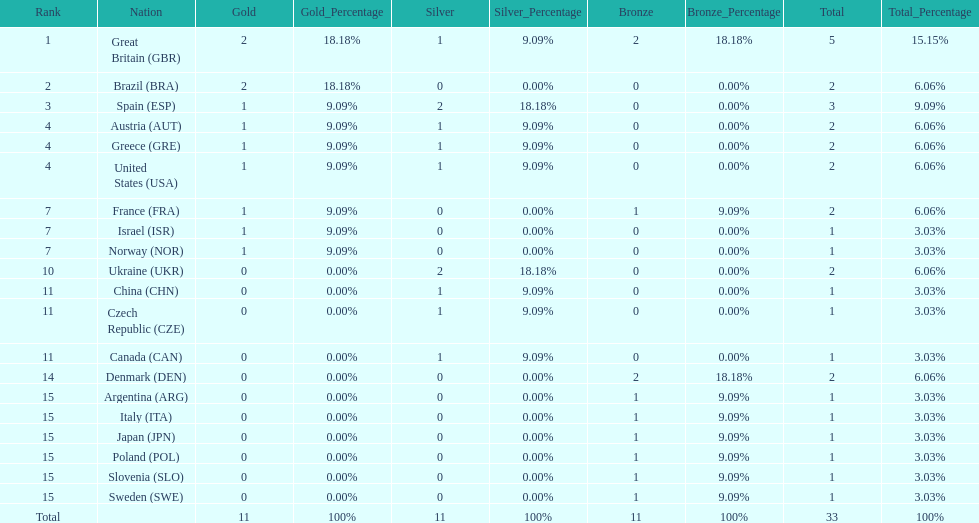How many gold medals did italy receive? 0. 